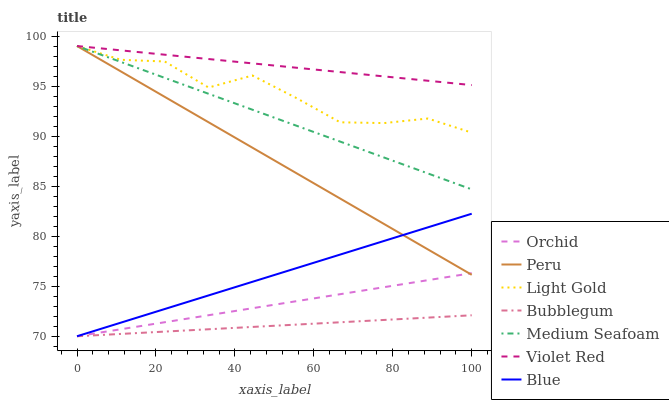Does Bubblegum have the minimum area under the curve?
Answer yes or no. Yes. Does Violet Red have the maximum area under the curve?
Answer yes or no. Yes. Does Violet Red have the minimum area under the curve?
Answer yes or no. No. Does Bubblegum have the maximum area under the curve?
Answer yes or no. No. Is Blue the smoothest?
Answer yes or no. Yes. Is Light Gold the roughest?
Answer yes or no. Yes. Is Violet Red the smoothest?
Answer yes or no. No. Is Violet Red the roughest?
Answer yes or no. No. Does Violet Red have the lowest value?
Answer yes or no. No. Does Medium Seafoam have the highest value?
Answer yes or no. Yes. Does Bubblegum have the highest value?
Answer yes or no. No. Is Bubblegum less than Medium Seafoam?
Answer yes or no. Yes. Is Medium Seafoam greater than Bubblegum?
Answer yes or no. Yes. Does Peru intersect Light Gold?
Answer yes or no. Yes. Is Peru less than Light Gold?
Answer yes or no. No. Is Peru greater than Light Gold?
Answer yes or no. No. Does Bubblegum intersect Medium Seafoam?
Answer yes or no. No. 